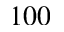<formula> <loc_0><loc_0><loc_500><loc_500>1 0 0</formula> 